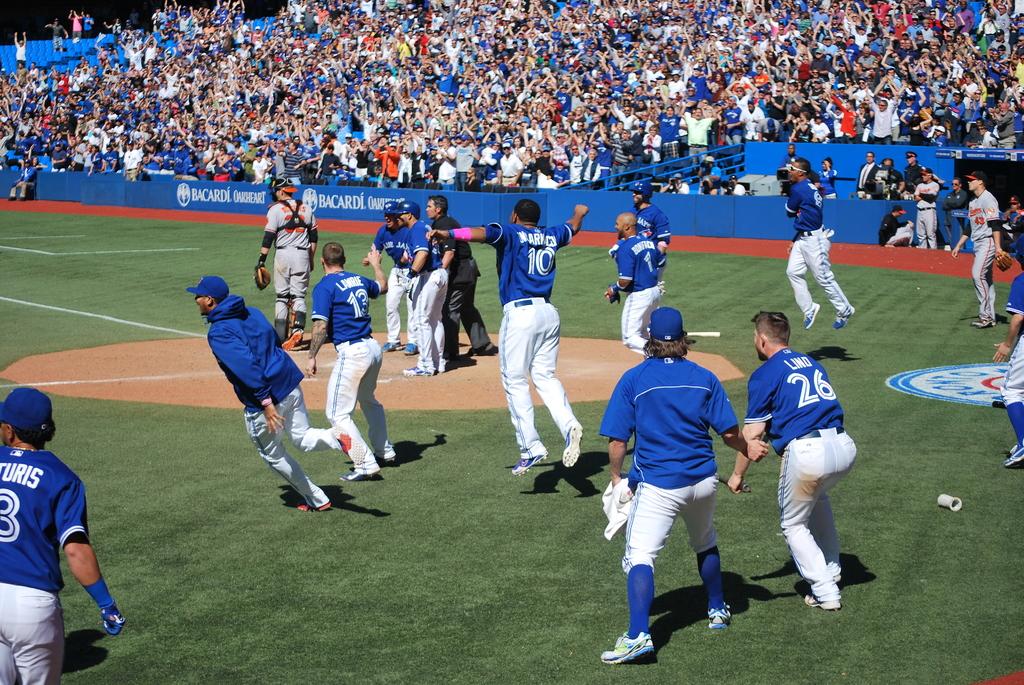What is the number of the jersey on the man with the pink arm band?
Ensure brevity in your answer.  10. 